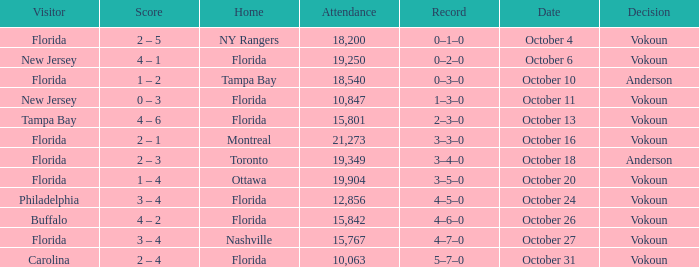What was the score on October 31? 2 – 4. 